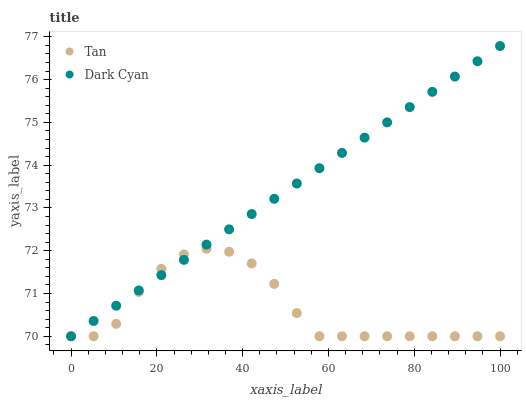Does Tan have the minimum area under the curve?
Answer yes or no. Yes. Does Dark Cyan have the maximum area under the curve?
Answer yes or no. Yes. Does Tan have the maximum area under the curve?
Answer yes or no. No. Is Dark Cyan the smoothest?
Answer yes or no. Yes. Is Tan the roughest?
Answer yes or no. Yes. Is Tan the smoothest?
Answer yes or no. No. Does Dark Cyan have the lowest value?
Answer yes or no. Yes. Does Dark Cyan have the highest value?
Answer yes or no. Yes. Does Tan have the highest value?
Answer yes or no. No. Does Dark Cyan intersect Tan?
Answer yes or no. Yes. Is Dark Cyan less than Tan?
Answer yes or no. No. Is Dark Cyan greater than Tan?
Answer yes or no. No. 